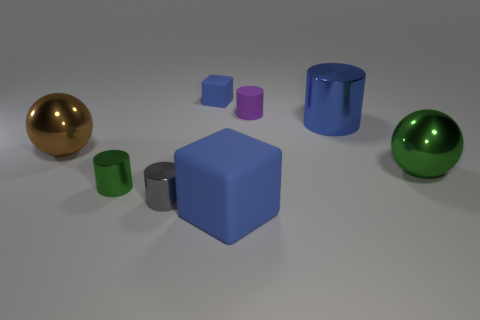Can you tell me the colors of the objects in the image? Certainly! From left to right, there's a golden ball, a green cup, a blue cube, a large blue cylinder, a small purple cube, a small magenta cylinder, and a shiny green ball. 